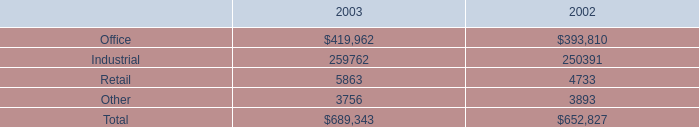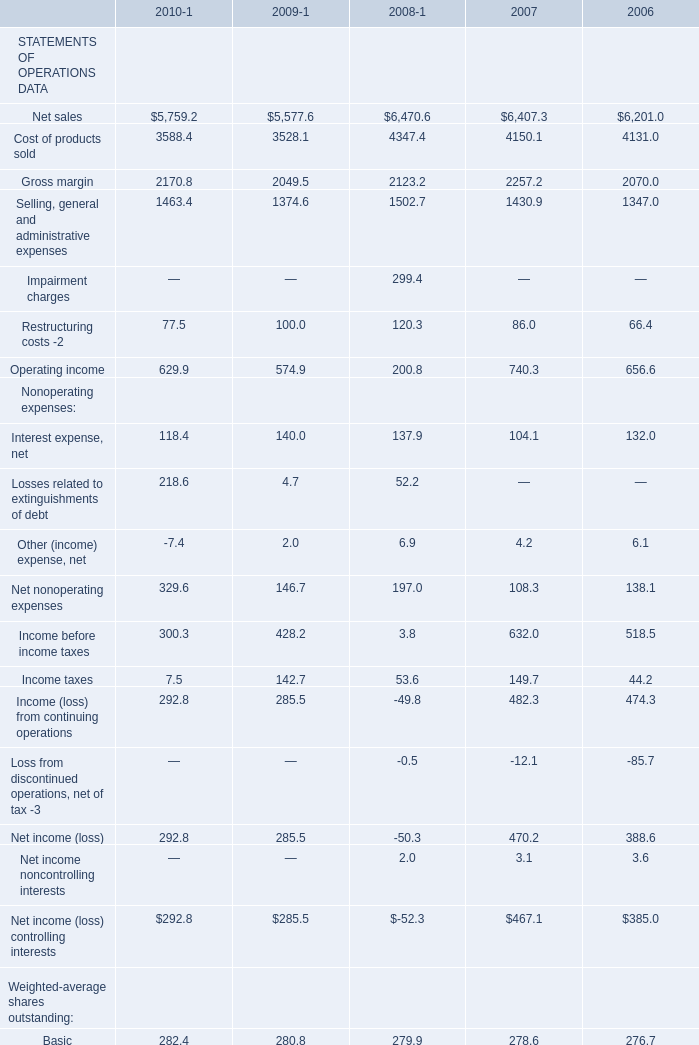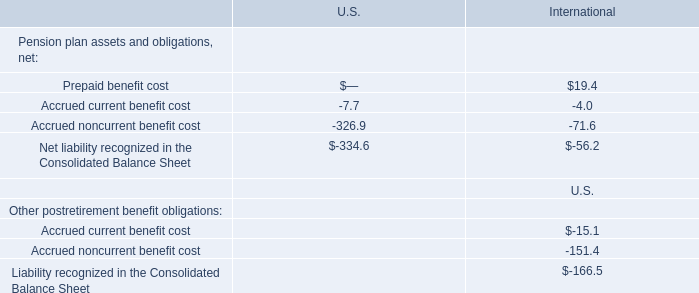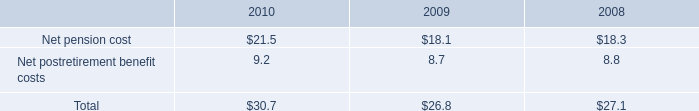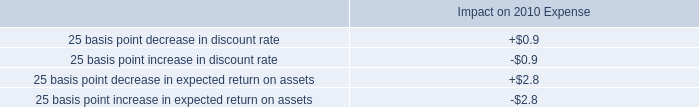What was the total amount of the Basic: Income (loss) from continuing operations in the years where Nonoperating expenses: Interest expense, net greater than 135? 
Computations: (1.02 - 0.18)
Answer: 0.84. 